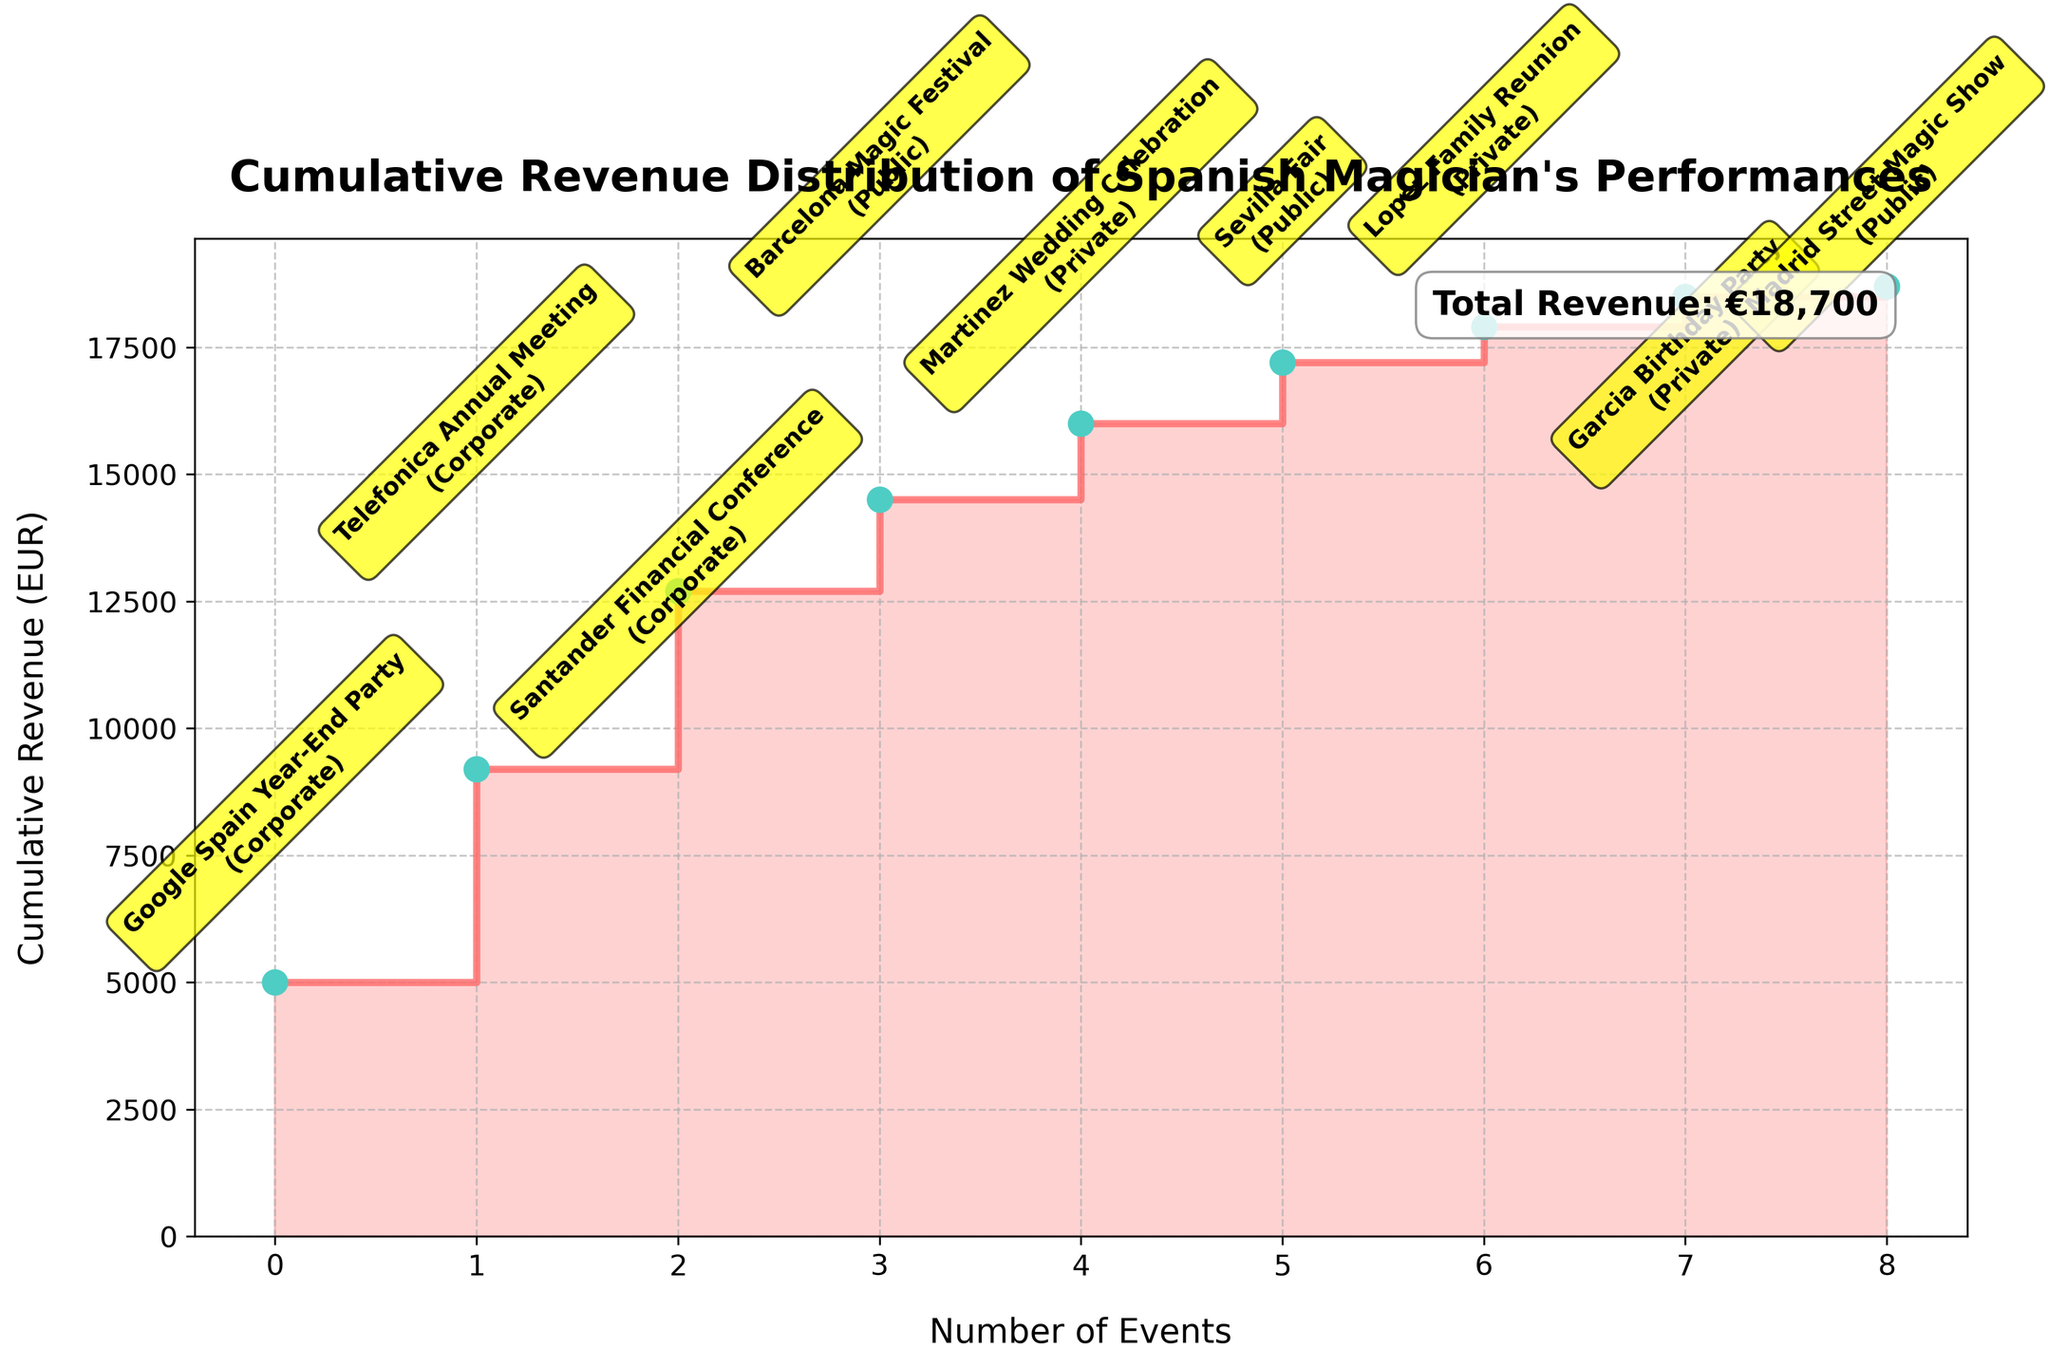How many event types are depicted in the plot? The plot's annotations and labels reveal three distinct event types: Corporate, Private, and Public. These types are highlighted next to each event name.
Answer: 3 Which event generated the highest revenue? The event with the highest cumulative jump on the plot is visually identified by the furthest upward step. The annotation for "Google Spain Year-End Party (Corporate)" at the highest step confirms it generates the most revenue.
Answer: Google Spain Year-End Party What is the total cumulative revenue by the fifth event? We need to identify the revenue values of the first five events after they are sorted. The events and their revenues (sorted) are: Google Spain Year-End Party (5000), Telefonica Annual Meeting (4200), Santander Financial Conference (3500), Barcelona Magic Festival (1800), Sevilla Fair (1200). The total revenue is 5000 + 4200 + 3500 + 1800 + 1200 = 15700.
Answer: 15700 EUR What is the cumulative revenue after the "Lopez Family Reunion"? Locate "Lopez Family Reunion (Private)" in the stair plot. The cumulative value directly after this event can be read or inferred, which is the total of all preceding revenues. The preliminary total adds 700 on top of prior cumulative revenues. From the previous cumulative sum logic, it is 18,700 (from previous) + 700 = 19,400.
Answer: 19400 EUR Between "Madrid Street Magic Show" and "Telefonica Annual Meeting", which event generated more revenue? Identify both events in the plot. The height step comparison shows that "Telefonica Annual Meeting (Corporate)" generated greater revenue when compared to "Madrid Street Magic Show (Public)".
Answer: Telefonica Annual Meeting What is the total revenue generated from Corporate events? Sum only the Corporate events revenues from the dataset: Google Spain Year-End Party (5000), Santander Financial Conference (3500), Telefonica Annual Meeting (4200). The total is 5000 + 3500 + 4200 = 12700.
Answer: 12700 EUR How does the cumulative revenue change from the second to the third highest revenue-generating event? Identify the second (Telefonica Annual Meeting) and third (Santander Financial Conference) events on the stair plot. The cumulative revenue increases from 5000 (Google Spain Year-End Party) + 4200 (Telefonica Annual Meeting) = 9200 to the next cumulative value 9200 + 3500 (Santander Financial Conference) = 12700 EUR. The change is 12700 - 9200.
Answer: 3500 EUR Which event from the private event category generated the highest revenue? Among private events shown, identifying the highest annotation step within 'Private' annotations reveals "Martinez Wedding Celebration (Private)" as the most profitable.
Answer: Martinez Wedding Celebration What percentage of the total revenue came from the "Barcelona Magic Festival"? The total revenue is 19500 EUR. The Barcelona Magic Festival generated 1800 EUR. Thus, the percentage is (1800/19500) * 100, which simplifies to approximately 9.23%.
Answer: 9.23% Which event shows the smallest incremental jump on the stair plot? Identify the smallest revenue step directly from the plot annotations. The "Madrid Street Magic Show (Public)" noted at a slight step confirms the lowest revenue.
Answer: Madrid Street Magic Show 